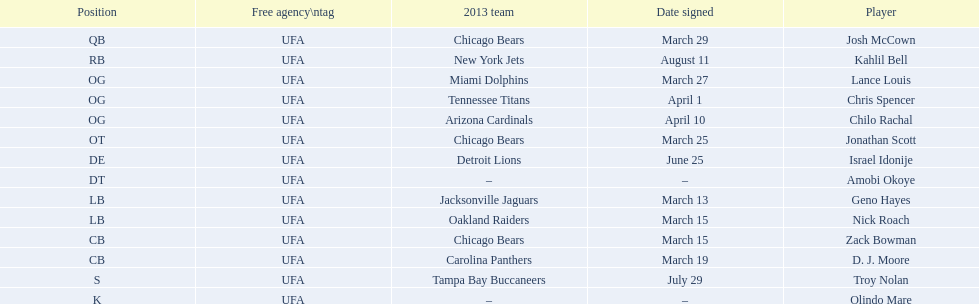Nick roach was signed the same day as what other player? Zack Bowman. 